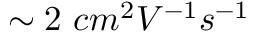Convert formula to latex. <formula><loc_0><loc_0><loc_500><loc_500>\sim 2 \ c m ^ { 2 } V ^ { - 1 } s ^ { - 1 }</formula> 